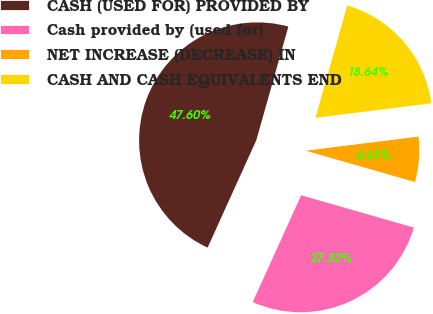<chart> <loc_0><loc_0><loc_500><loc_500><pie_chart><fcel>CASH (USED FOR) PROVIDED BY<fcel>Cash provided by (used for)<fcel>NET INCREASE (DECREASE) IN<fcel>CASH AND CASH EQUIVALENTS END<nl><fcel>47.6%<fcel>27.32%<fcel>6.43%<fcel>18.64%<nl></chart> 